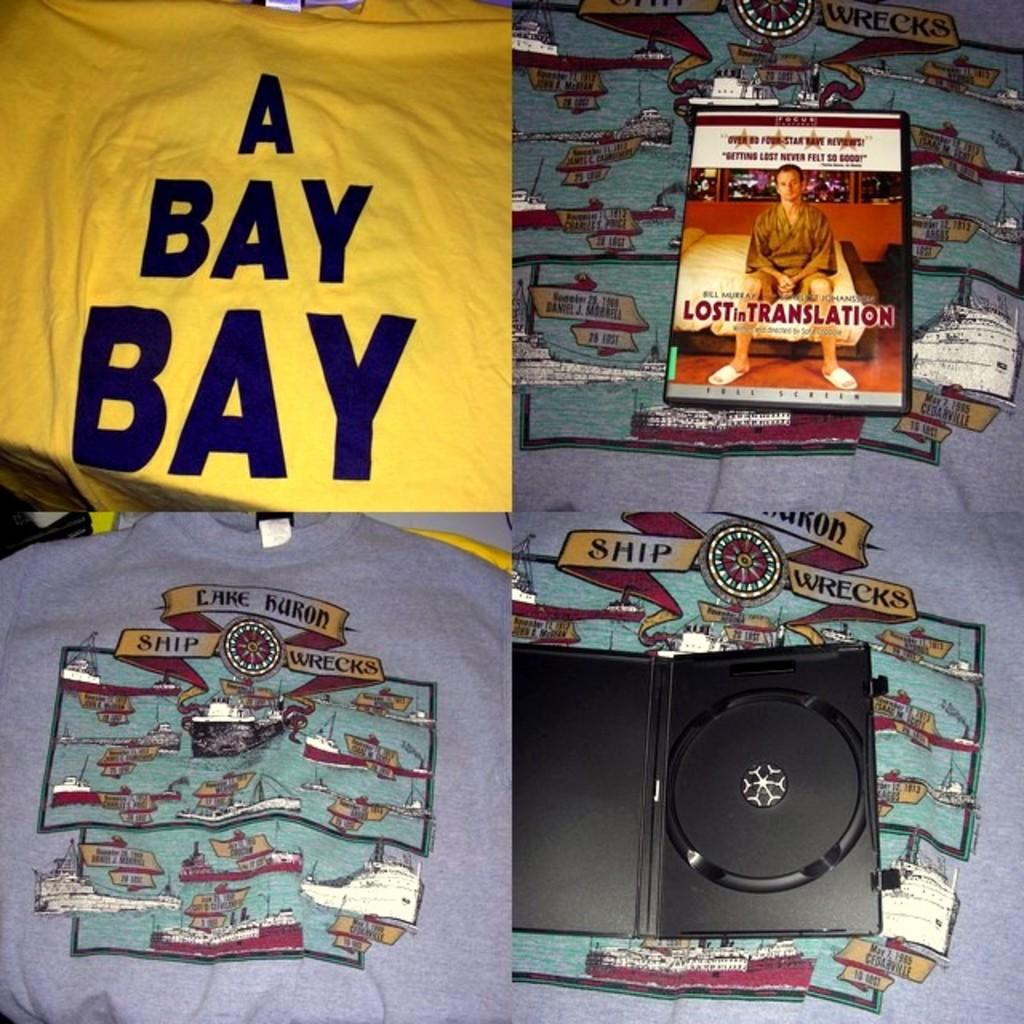<image>
Share a concise interpretation of the image provided. One one side of the screen you will see an open DVD cover and a DVD of the movie "Lost in Translation. 